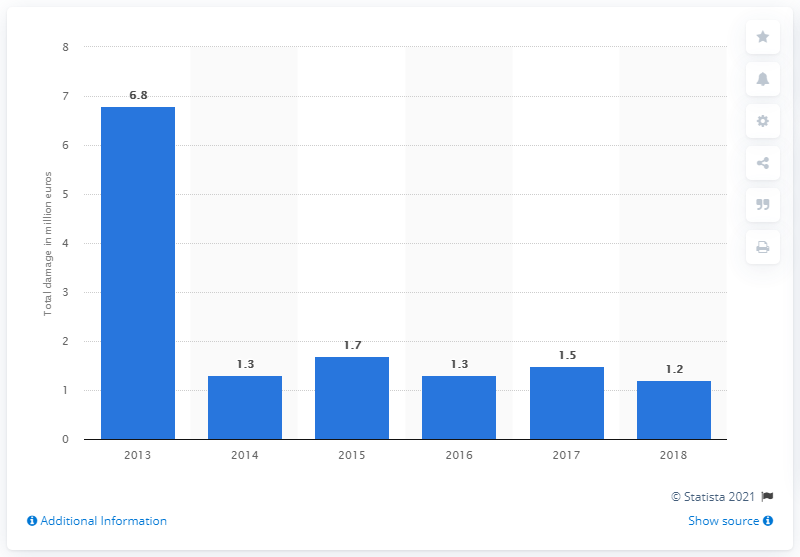Outline some significant characteristics in this image. The total damage caused by debit card skimming in the Netherlands in 2018 was 1.2 million euros. 